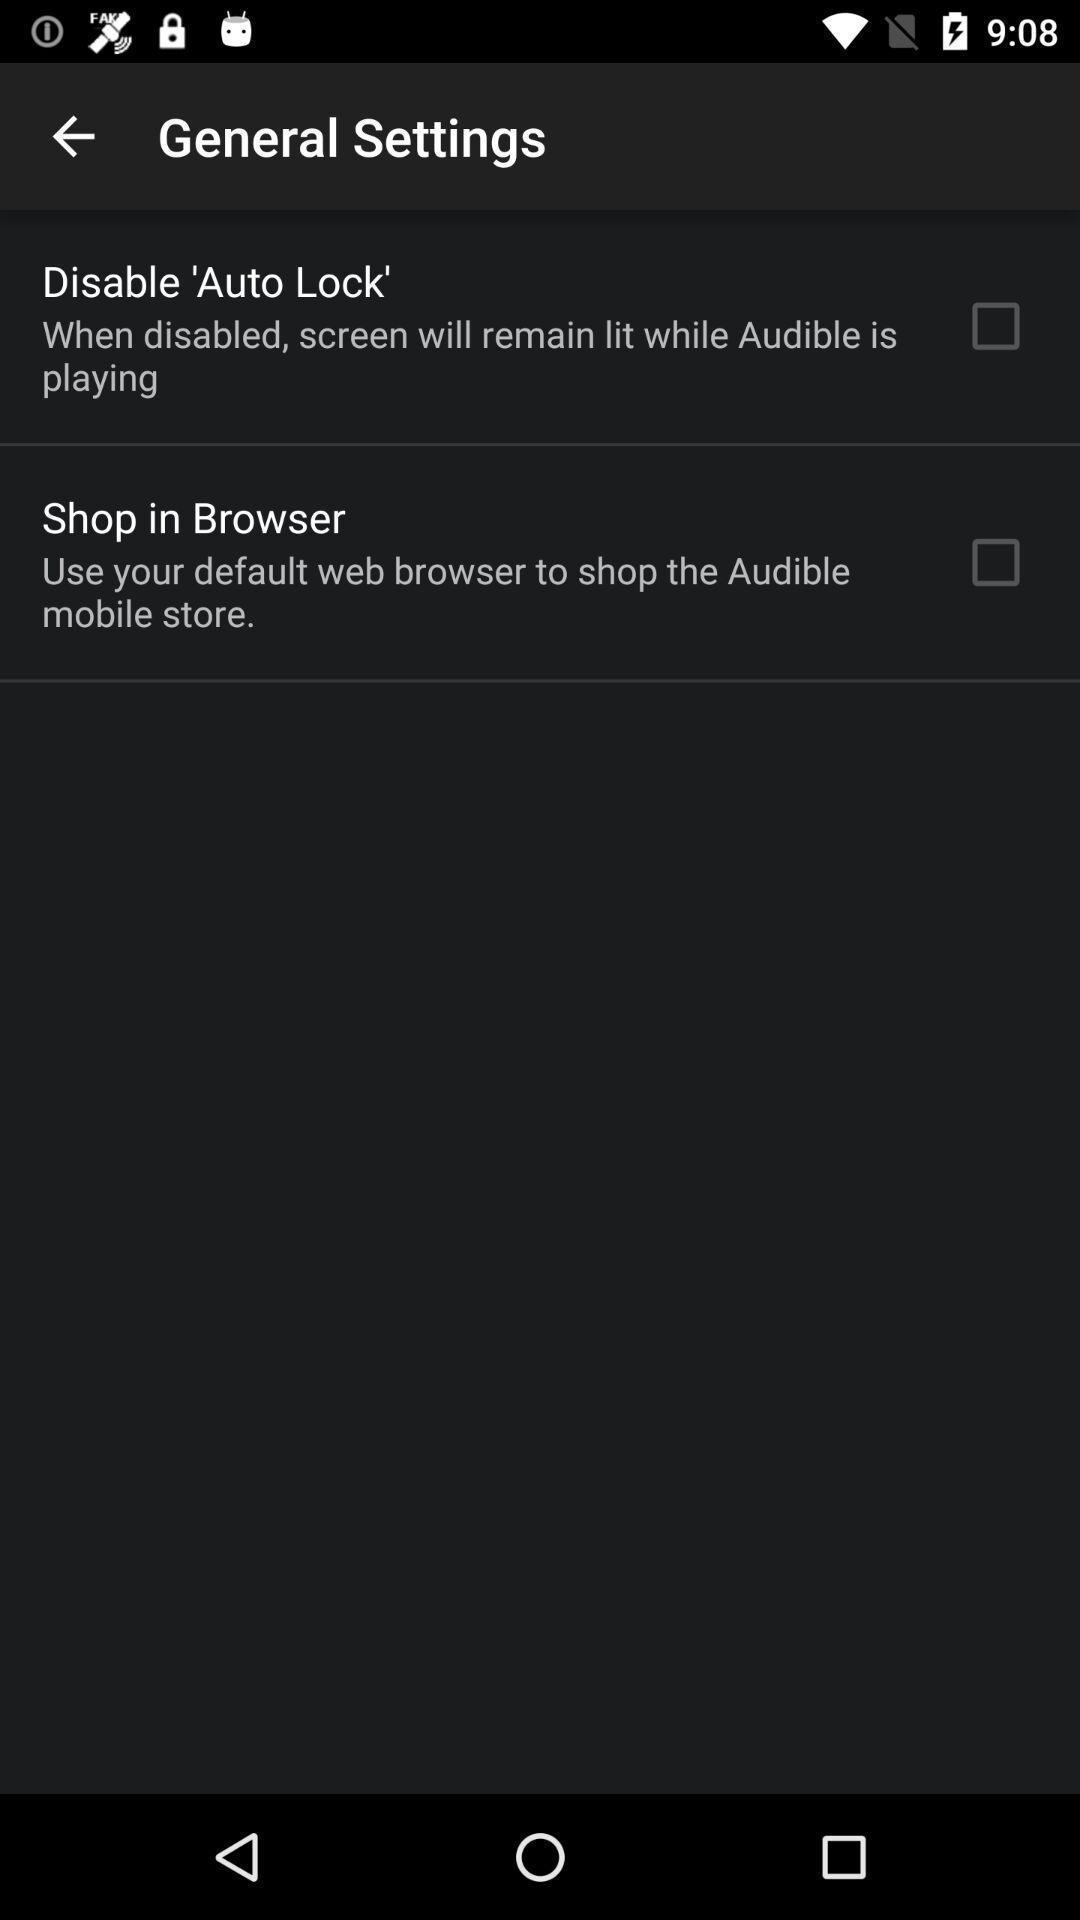Give me a narrative description of this picture. Page displaying with list of different settings. 